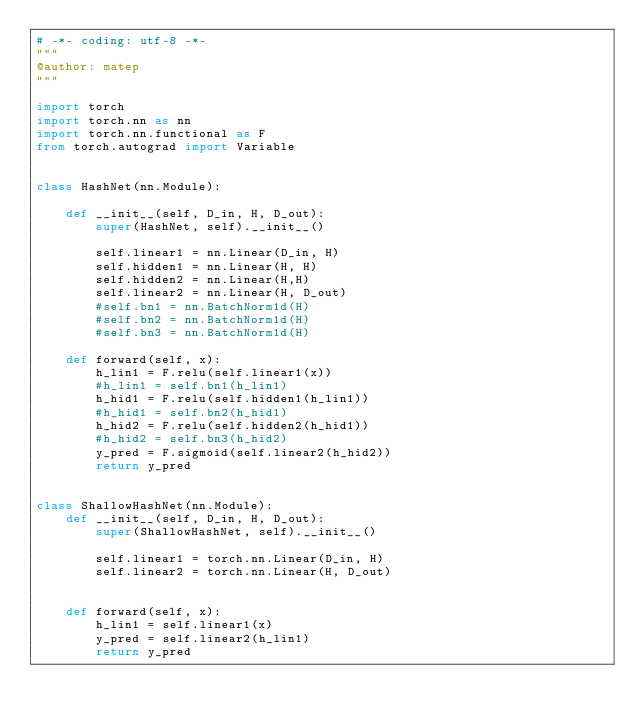Convert code to text. <code><loc_0><loc_0><loc_500><loc_500><_Python_># -*- coding: utf-8 -*-
"""
@author: matep
"""

import torch 
import torch.nn as nn
import torch.nn.functional as F
from torch.autograd import Variable


class HashNet(nn.Module):
    
    def __init__(self, D_in, H, D_out):
        super(HashNet, self).__init__()
        
        self.linear1 = nn.Linear(D_in, H)
        self.hidden1 = nn.Linear(H, H)
        self.hidden2 = nn.Linear(H,H)
        self.linear2 = nn.Linear(H, D_out)
        #self.bn1 = nn.BatchNorm1d(H)
        #self.bn2 = nn.BatchNorm1d(H)
        #self.bn3 = nn.BatchNorm1d(H)
        
    def forward(self, x):
        h_lin1 = F.relu(self.linear1(x))
        #h_lin1 = self.bn1(h_lin1)
        h_hid1 = F.relu(self.hidden1(h_lin1))
        #h_hid1 = self.bn2(h_hid1)
        h_hid2 = F.relu(self.hidden2(h_hid1))
        #h_hid2 = self.bn3(h_hid2)
        y_pred = F.sigmoid(self.linear2(h_hid2))
        return y_pred
    
    
class ShallowHashNet(nn.Module):
    def __init__(self, D_in, H, D_out):
        super(ShallowHashNet, self).__init__()
        
        self.linear1 = torch.nn.Linear(D_in, H)
        self.linear2 = torch.nn.Linear(H, D_out)
        
    
    def forward(self, x):
        h_lin1 = self.linear1(x)
        y_pred = self.linear2(h_lin1)
        return y_pred
</code> 